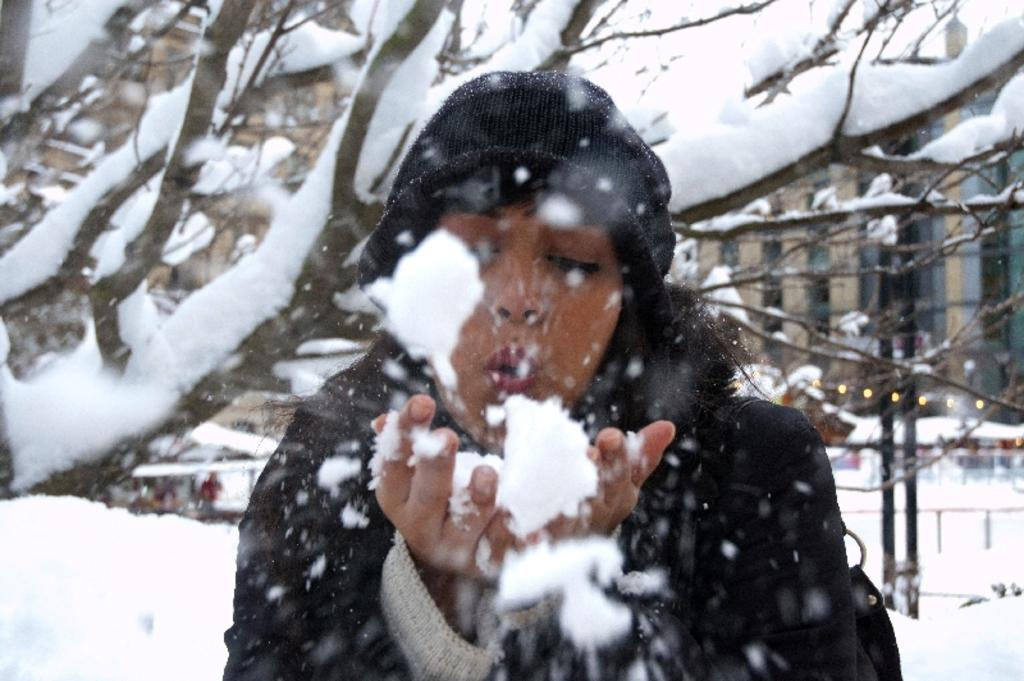Who is present in the image? There is a woman in the image. What is the woman wearing on her head? The woman is wearing a cap. What is on the woman's hands? The woman has snow on her hands. What can be seen in the background of the image? There are trees, buildings, lights, and poles in the background of the image. What is the overall condition of the scene in the image? The scene is covered with snow. What type of appliance can be seen in the woman's hands in the image? There is no appliance visible in the woman's hands in the image; she has snow on her hands. How many bears are visible in the image? There are no bears present in the image. 